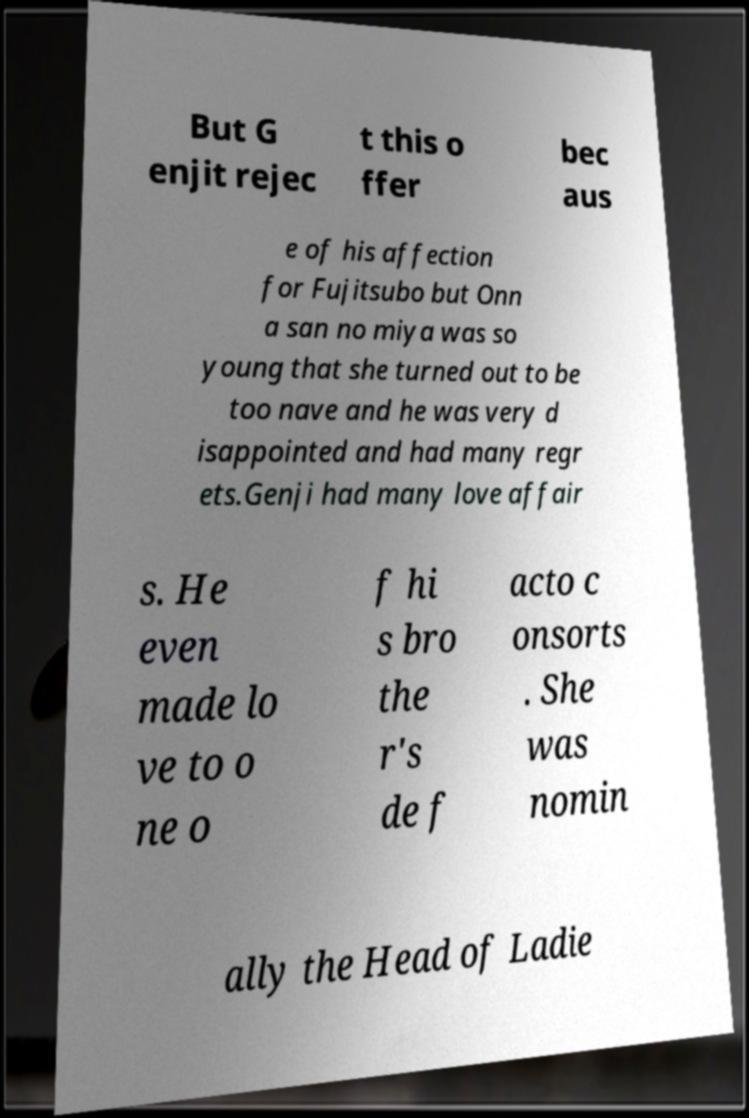Please identify and transcribe the text found in this image. But G enjit rejec t this o ffer bec aus e of his affection for Fujitsubo but Onn a san no miya was so young that she turned out to be too nave and he was very d isappointed and had many regr ets.Genji had many love affair s. He even made lo ve to o ne o f hi s bro the r's de f acto c onsorts . She was nomin ally the Head of Ladie 